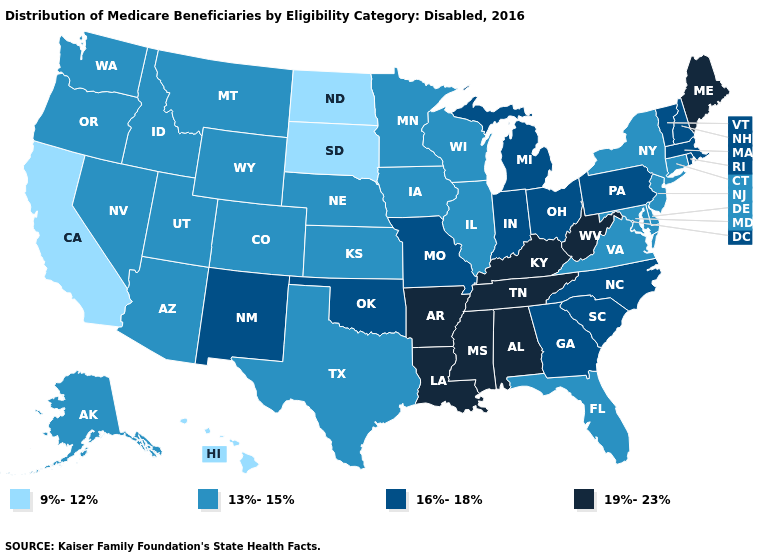Does Washington have a higher value than Kentucky?
Short answer required. No. Does the map have missing data?
Answer briefly. No. Which states have the lowest value in the West?
Answer briefly. California, Hawaii. Does Minnesota have the highest value in the MidWest?
Keep it brief. No. Among the states that border Connecticut , which have the highest value?
Write a very short answer. Massachusetts, Rhode Island. Name the states that have a value in the range 13%-15%?
Be succinct. Alaska, Arizona, Colorado, Connecticut, Delaware, Florida, Idaho, Illinois, Iowa, Kansas, Maryland, Minnesota, Montana, Nebraska, Nevada, New Jersey, New York, Oregon, Texas, Utah, Virginia, Washington, Wisconsin, Wyoming. Name the states that have a value in the range 9%-12%?
Give a very brief answer. California, Hawaii, North Dakota, South Dakota. Which states have the lowest value in the USA?
Keep it brief. California, Hawaii, North Dakota, South Dakota. Name the states that have a value in the range 13%-15%?
Be succinct. Alaska, Arizona, Colorado, Connecticut, Delaware, Florida, Idaho, Illinois, Iowa, Kansas, Maryland, Minnesota, Montana, Nebraska, Nevada, New Jersey, New York, Oregon, Texas, Utah, Virginia, Washington, Wisconsin, Wyoming. Name the states that have a value in the range 19%-23%?
Write a very short answer. Alabama, Arkansas, Kentucky, Louisiana, Maine, Mississippi, Tennessee, West Virginia. What is the value of Florida?
Write a very short answer. 13%-15%. Name the states that have a value in the range 9%-12%?
Give a very brief answer. California, Hawaii, North Dakota, South Dakota. Does the map have missing data?
Concise answer only. No. Among the states that border Rhode Island , which have the highest value?
Write a very short answer. Massachusetts. Among the states that border Michigan , does Indiana have the lowest value?
Keep it brief. No. 